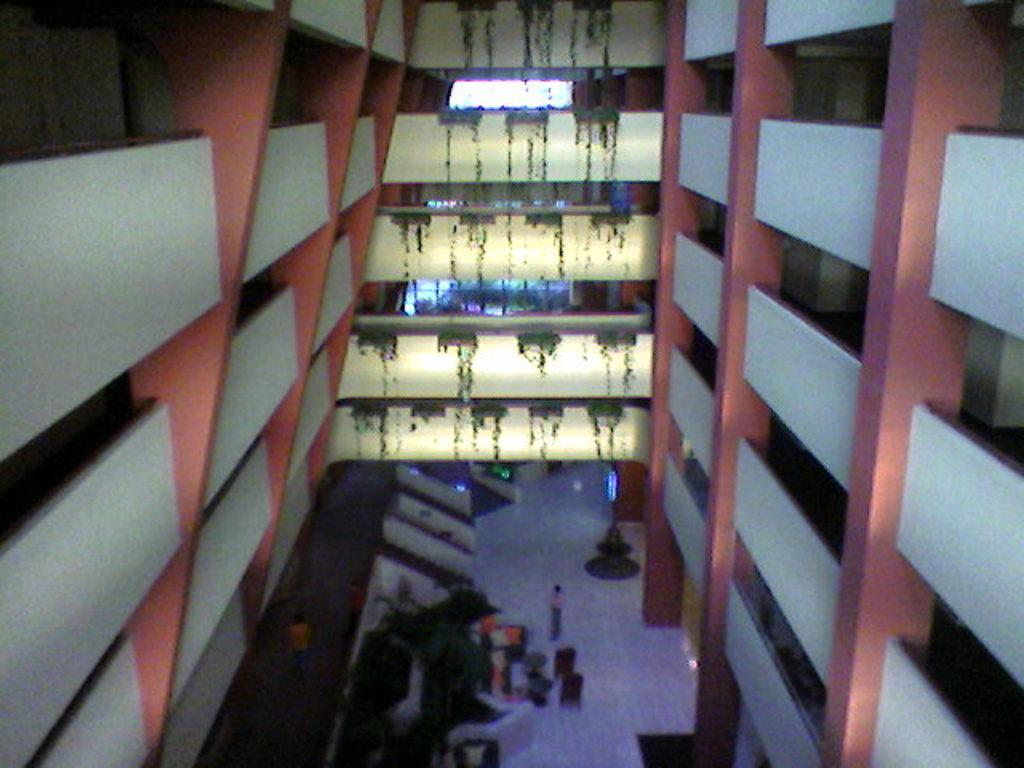What type of structures can be seen on the right side of the image? There are buildings on the right side of the image. What type of structures can be seen on the left side of the image? There are buildings on the left side of the image. Can you describe the people at the bottom side of the image? The people are at the bottom side of the image. What type of class is being taught in the image? There is no class or teaching activity present in the image. 